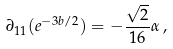<formula> <loc_0><loc_0><loc_500><loc_500>\partial _ { 1 1 } ( e ^ { - 3 b / 2 } ) = - \frac { \sqrt { 2 } } { 1 6 } \alpha \, ,</formula> 